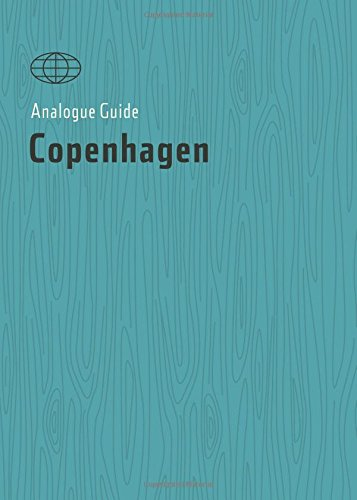What is the title of this book? The title of the book is 'Analogue Guide Copenhagen (Analogue Guides)', which provides detailed insights into exploring Copenhagen. 